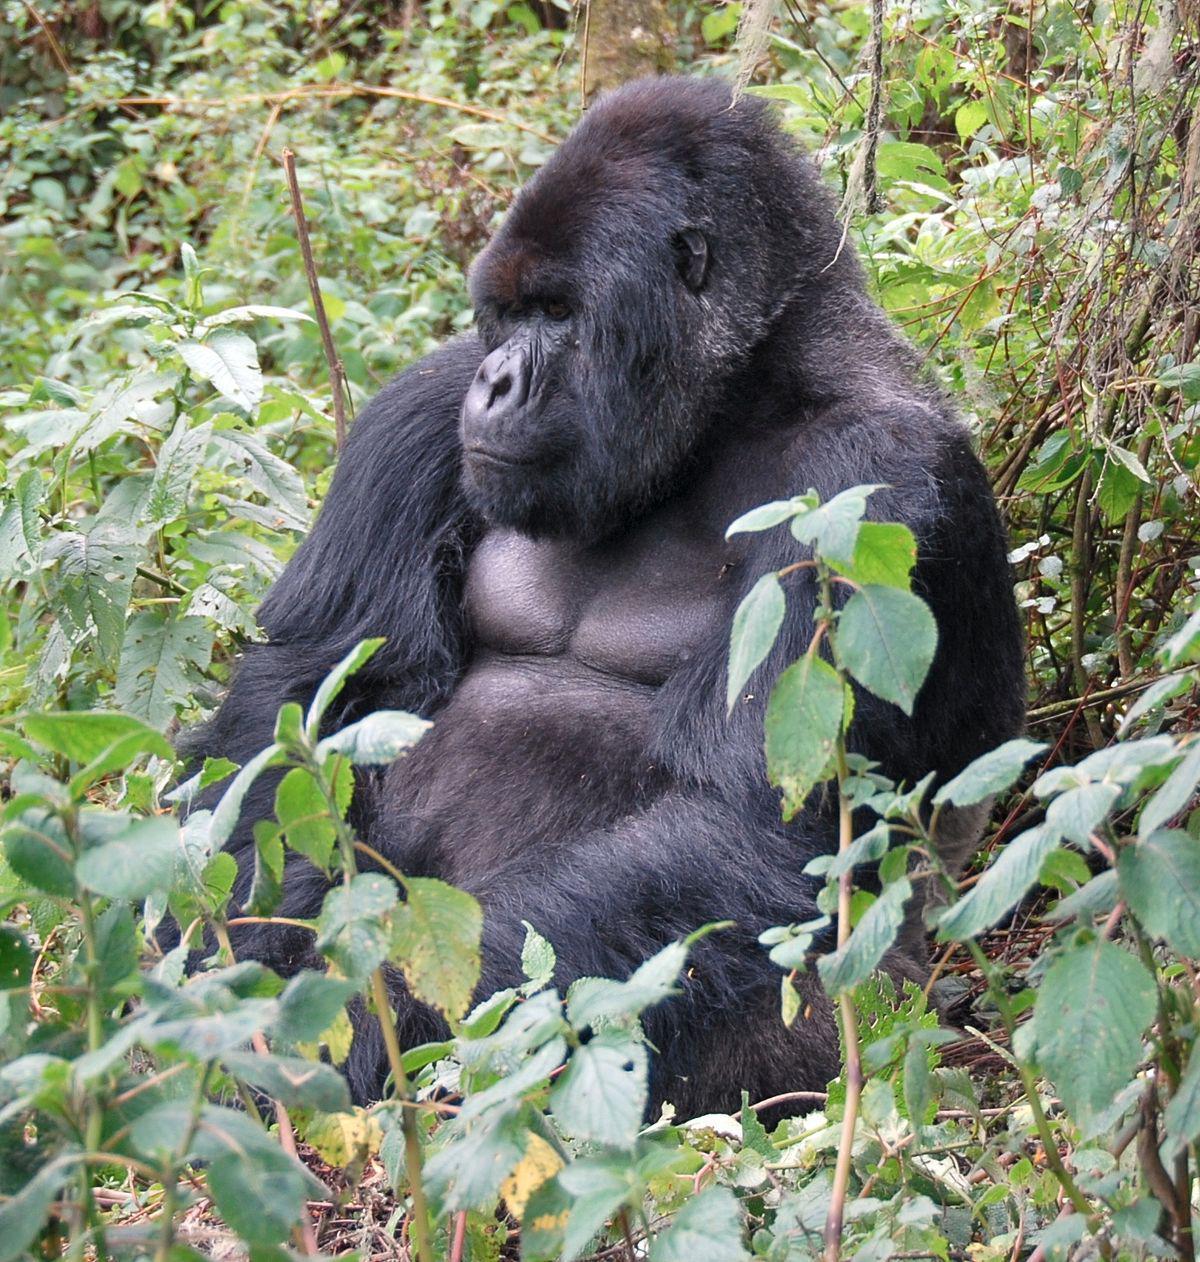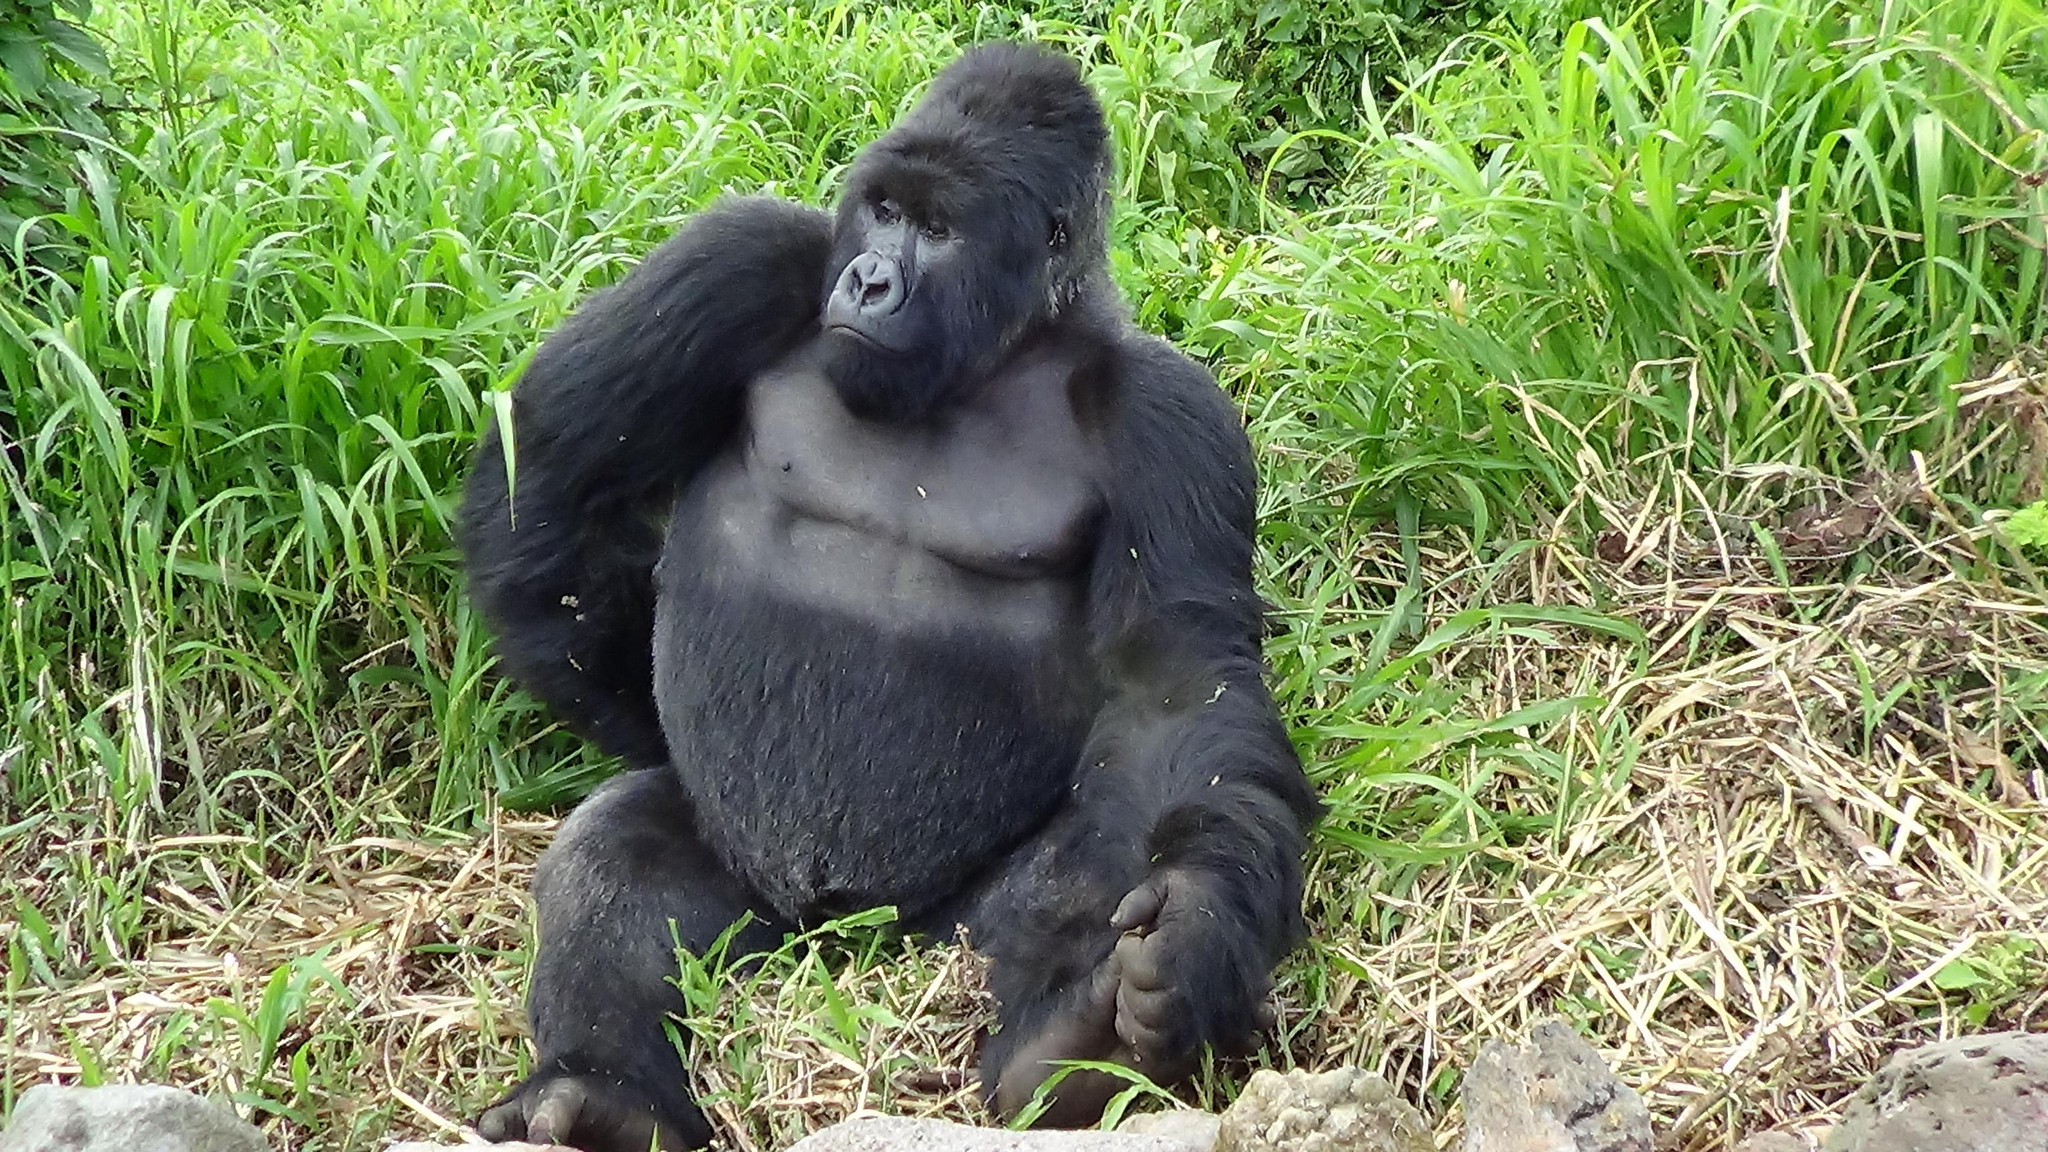The first image is the image on the left, the second image is the image on the right. Examine the images to the left and right. Is the description "There are no more than two gorillas in the right image." accurate? Answer yes or no. Yes. The first image is the image on the left, the second image is the image on the right. Analyze the images presented: Is the assertion "At least one image contains no more than two gorillas and contains at least one adult male." valid? Answer yes or no. Yes. 